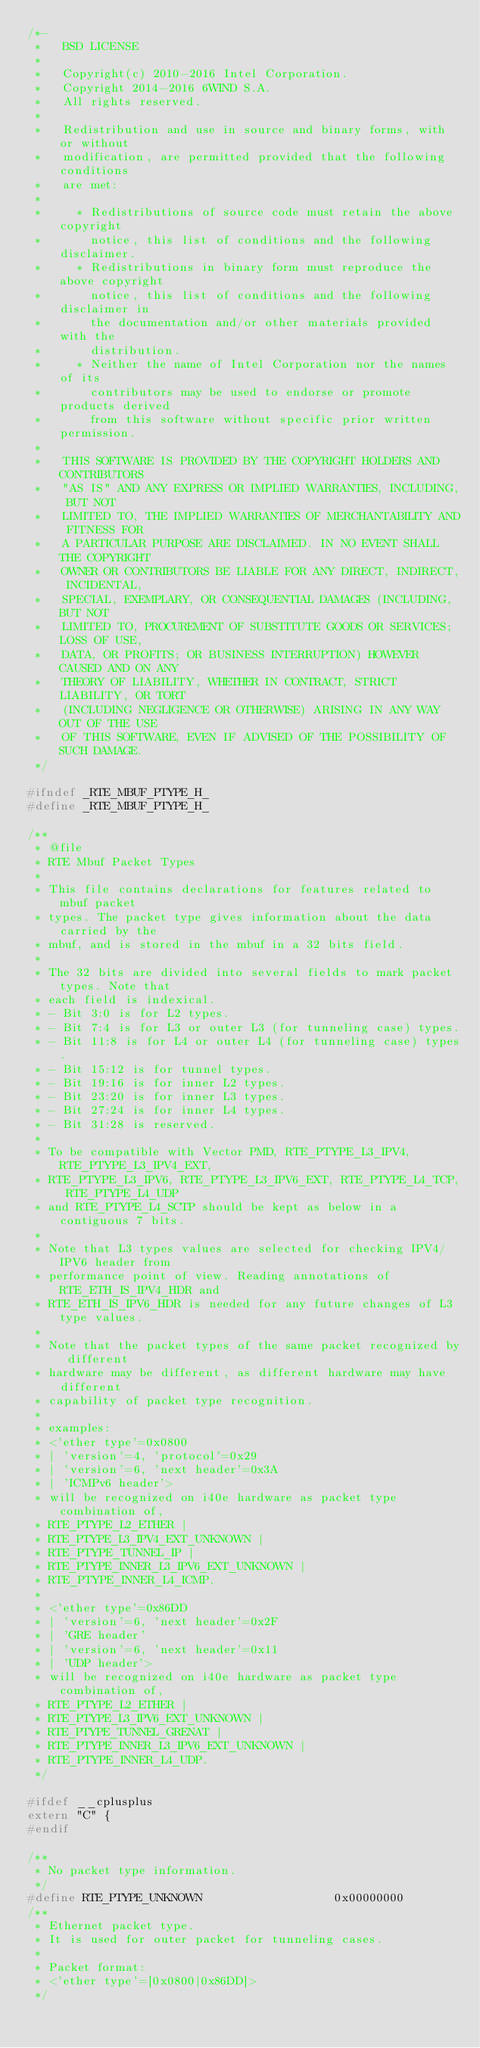Convert code to text. <code><loc_0><loc_0><loc_500><loc_500><_C_>/*-
 *   BSD LICENSE
 *
 *   Copyright(c) 2010-2016 Intel Corporation.
 *   Copyright 2014-2016 6WIND S.A.
 *   All rights reserved.
 *
 *   Redistribution and use in source and binary forms, with or without
 *   modification, are permitted provided that the following conditions
 *   are met:
 *
 *     * Redistributions of source code must retain the above copyright
 *       notice, this list of conditions and the following disclaimer.
 *     * Redistributions in binary form must reproduce the above copyright
 *       notice, this list of conditions and the following disclaimer in
 *       the documentation and/or other materials provided with the
 *       distribution.
 *     * Neither the name of Intel Corporation nor the names of its
 *       contributors may be used to endorse or promote products derived
 *       from this software without specific prior written permission.
 *
 *   THIS SOFTWARE IS PROVIDED BY THE COPYRIGHT HOLDERS AND CONTRIBUTORS
 *   "AS IS" AND ANY EXPRESS OR IMPLIED WARRANTIES, INCLUDING, BUT NOT
 *   LIMITED TO, THE IMPLIED WARRANTIES OF MERCHANTABILITY AND FITNESS FOR
 *   A PARTICULAR PURPOSE ARE DISCLAIMED. IN NO EVENT SHALL THE COPYRIGHT
 *   OWNER OR CONTRIBUTORS BE LIABLE FOR ANY DIRECT, INDIRECT, INCIDENTAL,
 *   SPECIAL, EXEMPLARY, OR CONSEQUENTIAL DAMAGES (INCLUDING, BUT NOT
 *   LIMITED TO, PROCUREMENT OF SUBSTITUTE GOODS OR SERVICES; LOSS OF USE,
 *   DATA, OR PROFITS; OR BUSINESS INTERRUPTION) HOWEVER CAUSED AND ON ANY
 *   THEORY OF LIABILITY, WHETHER IN CONTRACT, STRICT LIABILITY, OR TORT
 *   (INCLUDING NEGLIGENCE OR OTHERWISE) ARISING IN ANY WAY OUT OF THE USE
 *   OF THIS SOFTWARE, EVEN IF ADVISED OF THE POSSIBILITY OF SUCH DAMAGE.
 */

#ifndef _RTE_MBUF_PTYPE_H_
#define _RTE_MBUF_PTYPE_H_

/**
 * @file
 * RTE Mbuf Packet Types
 *
 * This file contains declarations for features related to mbuf packet
 * types. The packet type gives information about the data carried by the
 * mbuf, and is stored in the mbuf in a 32 bits field.
 *
 * The 32 bits are divided into several fields to mark packet types. Note that
 * each field is indexical.
 * - Bit 3:0 is for L2 types.
 * - Bit 7:4 is for L3 or outer L3 (for tunneling case) types.
 * - Bit 11:8 is for L4 or outer L4 (for tunneling case) types.
 * - Bit 15:12 is for tunnel types.
 * - Bit 19:16 is for inner L2 types.
 * - Bit 23:20 is for inner L3 types.
 * - Bit 27:24 is for inner L4 types.
 * - Bit 31:28 is reserved.
 *
 * To be compatible with Vector PMD, RTE_PTYPE_L3_IPV4, RTE_PTYPE_L3_IPV4_EXT,
 * RTE_PTYPE_L3_IPV6, RTE_PTYPE_L3_IPV6_EXT, RTE_PTYPE_L4_TCP, RTE_PTYPE_L4_UDP
 * and RTE_PTYPE_L4_SCTP should be kept as below in a contiguous 7 bits.
 *
 * Note that L3 types values are selected for checking IPV4/IPV6 header from
 * performance point of view. Reading annotations of RTE_ETH_IS_IPV4_HDR and
 * RTE_ETH_IS_IPV6_HDR is needed for any future changes of L3 type values.
 *
 * Note that the packet types of the same packet recognized by different
 * hardware may be different, as different hardware may have different
 * capability of packet type recognition.
 *
 * examples:
 * <'ether type'=0x0800
 * | 'version'=4, 'protocol'=0x29
 * | 'version'=6, 'next header'=0x3A
 * | 'ICMPv6 header'>
 * will be recognized on i40e hardware as packet type combination of,
 * RTE_PTYPE_L2_ETHER |
 * RTE_PTYPE_L3_IPV4_EXT_UNKNOWN |
 * RTE_PTYPE_TUNNEL_IP |
 * RTE_PTYPE_INNER_L3_IPV6_EXT_UNKNOWN |
 * RTE_PTYPE_INNER_L4_ICMP.
 *
 * <'ether type'=0x86DD
 * | 'version'=6, 'next header'=0x2F
 * | 'GRE header'
 * | 'version'=6, 'next header'=0x11
 * | 'UDP header'>
 * will be recognized on i40e hardware as packet type combination of,
 * RTE_PTYPE_L2_ETHER |
 * RTE_PTYPE_L3_IPV6_EXT_UNKNOWN |
 * RTE_PTYPE_TUNNEL_GRENAT |
 * RTE_PTYPE_INNER_L3_IPV6_EXT_UNKNOWN |
 * RTE_PTYPE_INNER_L4_UDP.
 */

#ifdef __cplusplus
extern "C" {
#endif

/**
 * No packet type information.
 */
#define RTE_PTYPE_UNKNOWN                   0x00000000
/**
 * Ethernet packet type.
 * It is used for outer packet for tunneling cases.
 *
 * Packet format:
 * <'ether type'=[0x0800|0x86DD]>
 */</code> 